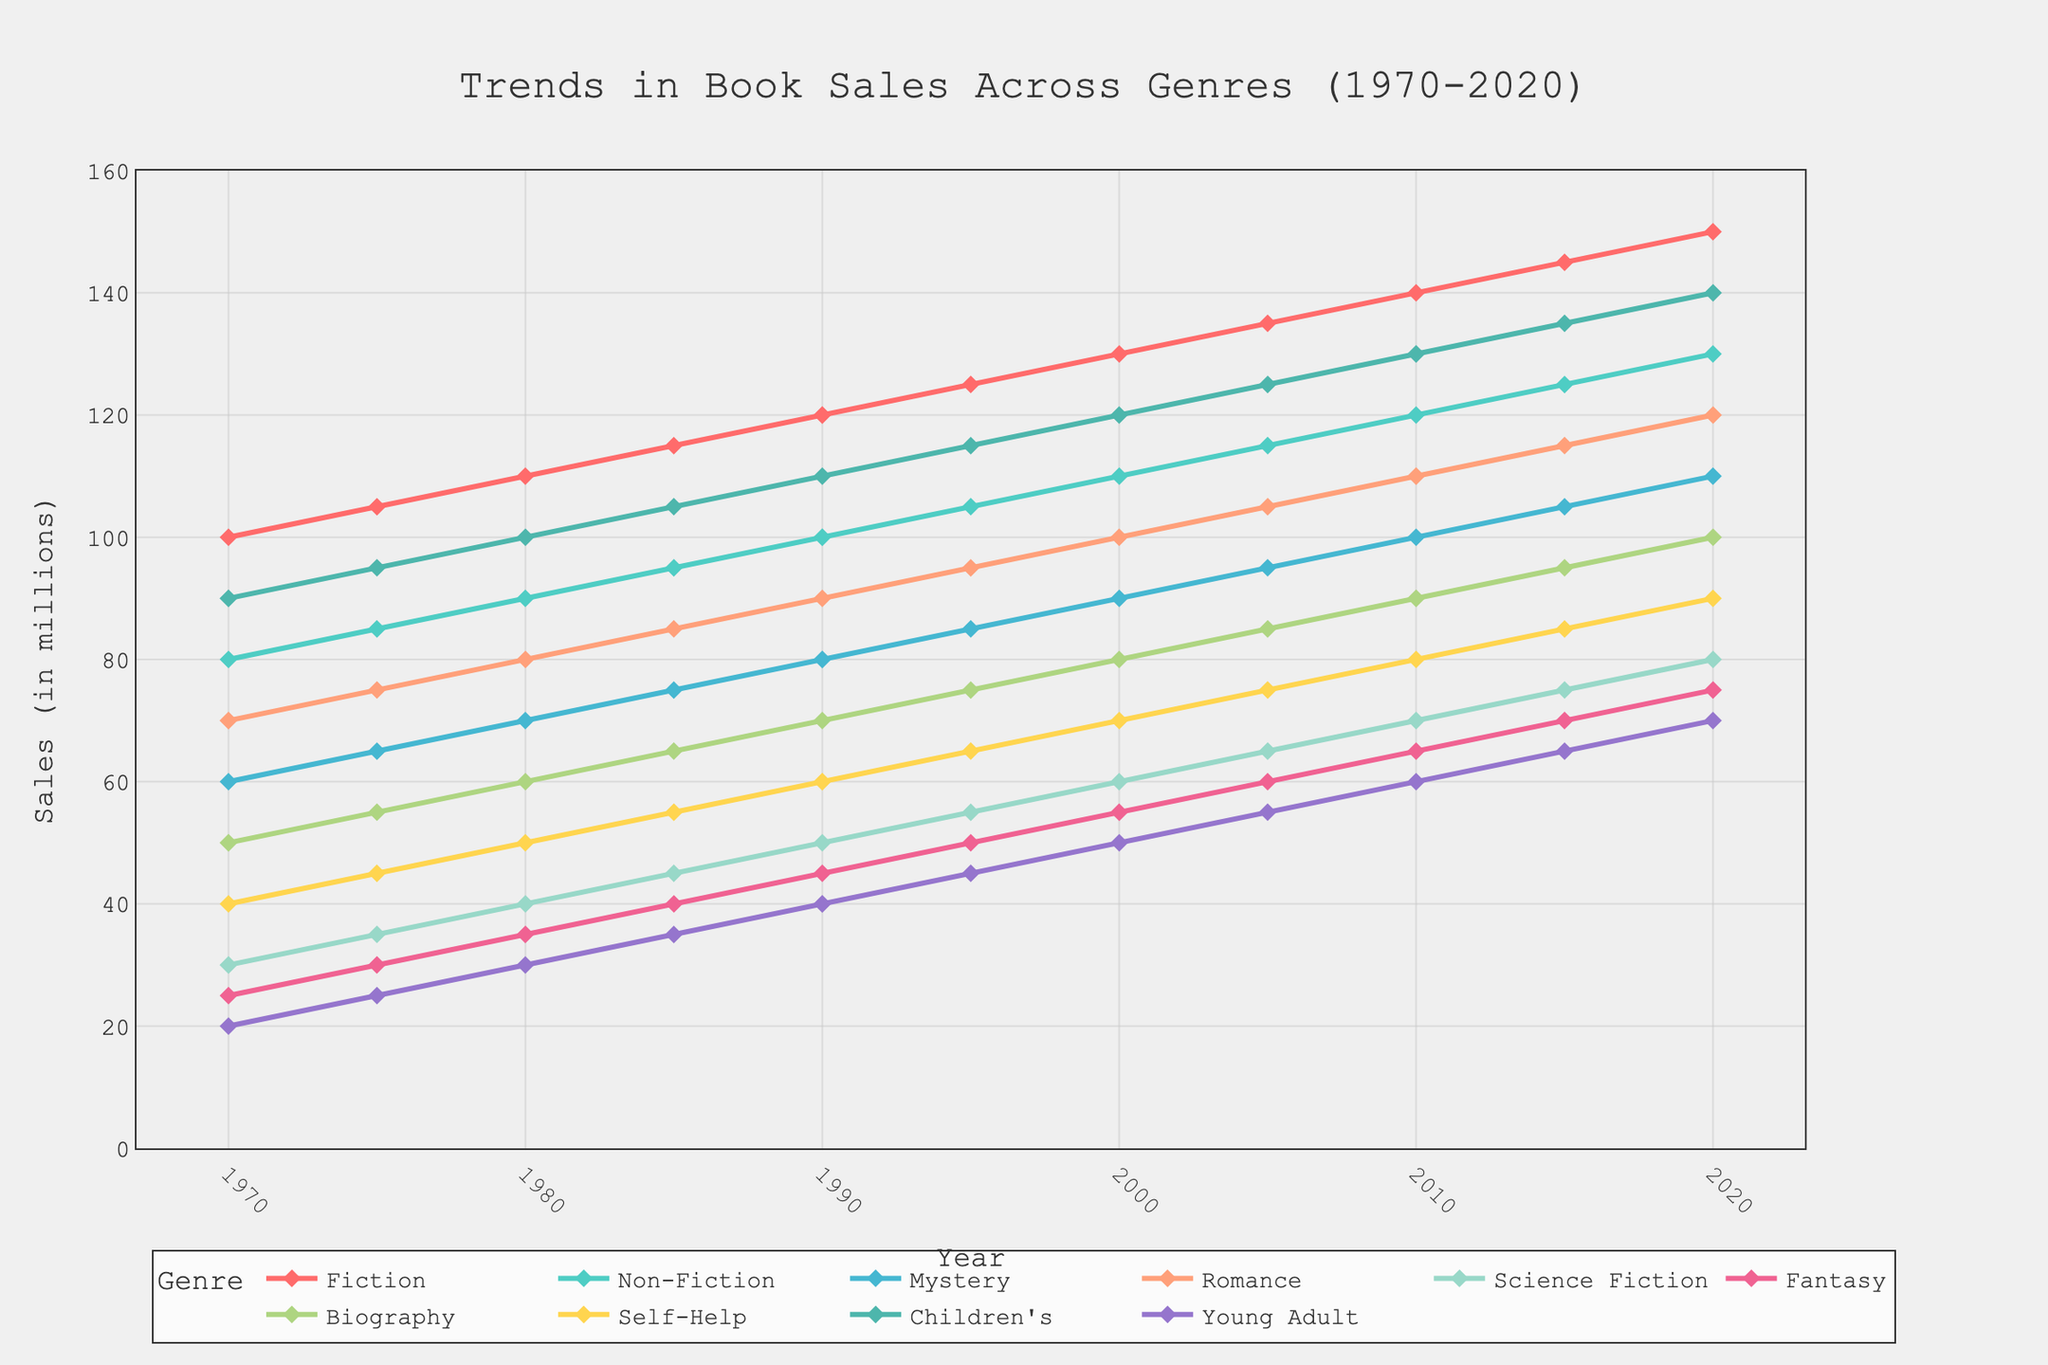What genre showed the highest sales increase from 1970 to 2020? Look at the lines on the chart, identify the start and end points for each genre, and calculate the difference. The genre with the highest increment represents the largest sales increase over the period.
Answer: Fiction Which genre had the least growth in sales from 1970 to 2020? Compare the difference in sales for each genre between 1970 and 2020 by subtracting the 1970 value from the 2020 value for each genre. The genre with the smallest increment represents the least growth.
Answer: Fantasy Within the decade of 2000 to 2010, which genre showed the most significant increase in sales? Identify the values for each genre in 2000 and 2010, then calculate the difference for the given period. The genre with the highest difference exhibits the most significant increase.
Answer: Fiction How does the sales trend of Romance compare to Science Fiction over the 50 years? Observe the lines representing Romance and Science Fiction. Compare the slope and overall growth of each. Determine which genre had higher sales in the initial years and if their trends diverged or converged.
Answer: Romance increased more consistently than Science Fiction Which genres had sales over 100 million in 1985? Locate the year 1985 on the x-axis and observe the corresponding y-values for each genre. Identify the genres with y-values exceeding 100.
Answer: Fiction, Non-Fiction, Children's What is the average sales of Mystery books from 1970 to 2020? Add the sales figures for Mystery across all years and divide by the number of data points (11 years) to obtain the average.
Answer: 85 Which genre had the closest sales numbers between 1990 and 2000? Look at the sales values for each genre in 1990 and 2000, then compare the numbers to determine the pair of genres with the smallest difference across that period.
Answer: Children's and Non-Fiction Describe the trend in Young Adult book sales after 1985. Observe the trajectory of the Young Adult line from 1985 onwards, noting if it rises, falls, or stabilizes.
Answer: Steadily increases How many genres had higher sales in 2010 than in 2000? Count the number of genres for which the sales figures in 2010 are greater than those in 2000.
Answer: 10 Which genre's sales numbers surpassed those of Self-Help in 1995 but were lower than Fiction in the same year? Compare the sales for all genres in 1995 with Self-Help sales and identify the ones that are higher. Then compare these to Fiction and identify those which are lower than Fiction.
Answer: Biography 